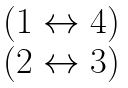<formula> <loc_0><loc_0><loc_500><loc_500>\begin{matrix} ( 1 \leftrightarrow 4 ) \\ ( 2 \leftrightarrow 3 ) \end{matrix}</formula> 